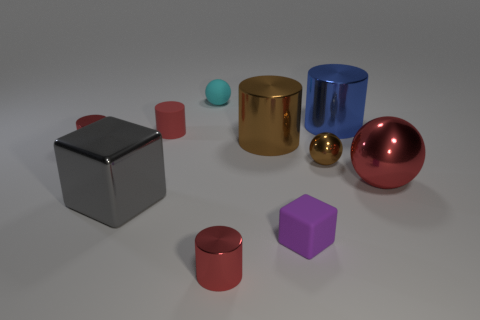There is a cylinder that is the same color as the small metal ball; what is its material? metal 